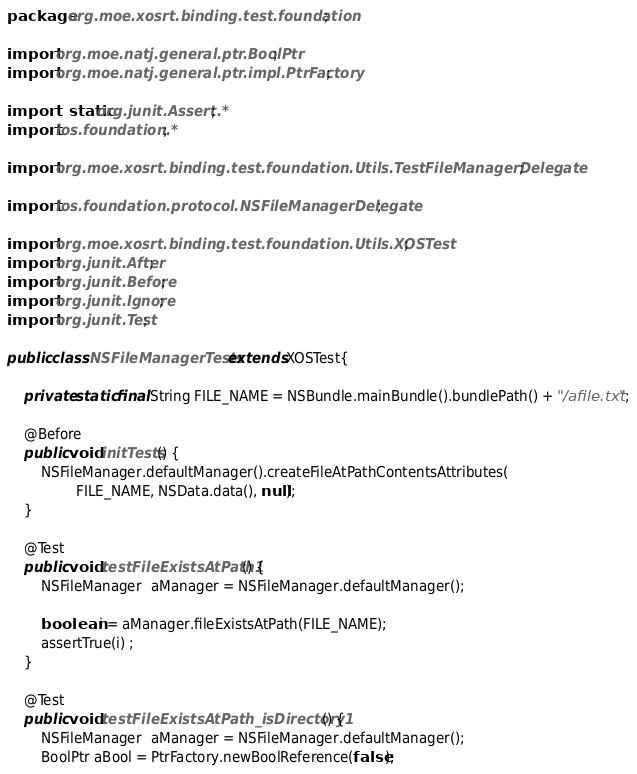Convert code to text. <code><loc_0><loc_0><loc_500><loc_500><_Java_>package org.moe.xosrt.binding.test.foundation;

import org.moe.natj.general.ptr.BoolPtr;
import org.moe.natj.general.ptr.impl.PtrFactory;

import static org.junit.Assert.*;
import ios.foundation.*;

import org.moe.xosrt.binding.test.foundation.Utils.TestFileManagerDelegate;

import ios.foundation.protocol.NSFileManagerDelegate;

import org.moe.xosrt.binding.test.foundation.Utils.XOSTest;
import org.junit.After;
import org.junit.Before;
import org.junit.Ignore;
import org.junit.Test;

public class NSFileManagerTests extends XOSTest{

    private static final String FILE_NAME = NSBundle.mainBundle().bundlePath() + "/afile.txt";

    @Before
    public void initTests() {
        NSFileManager.defaultManager().createFileAtPathContentsAttributes(
                FILE_NAME, NSData.data(), null);
    }

    @Test
    public void testFileExistsAtPath1() {
        NSFileManager  aManager = NSFileManager.defaultManager();

        boolean i = aManager.fileExistsAtPath(FILE_NAME);
        assertTrue(i) ;
    }

    @Test
    public void testFileExistsAtPath_isDirectory1() {
        NSFileManager  aManager = NSFileManager.defaultManager();
        BoolPtr aBool = PtrFactory.newBoolReference(false);</code> 